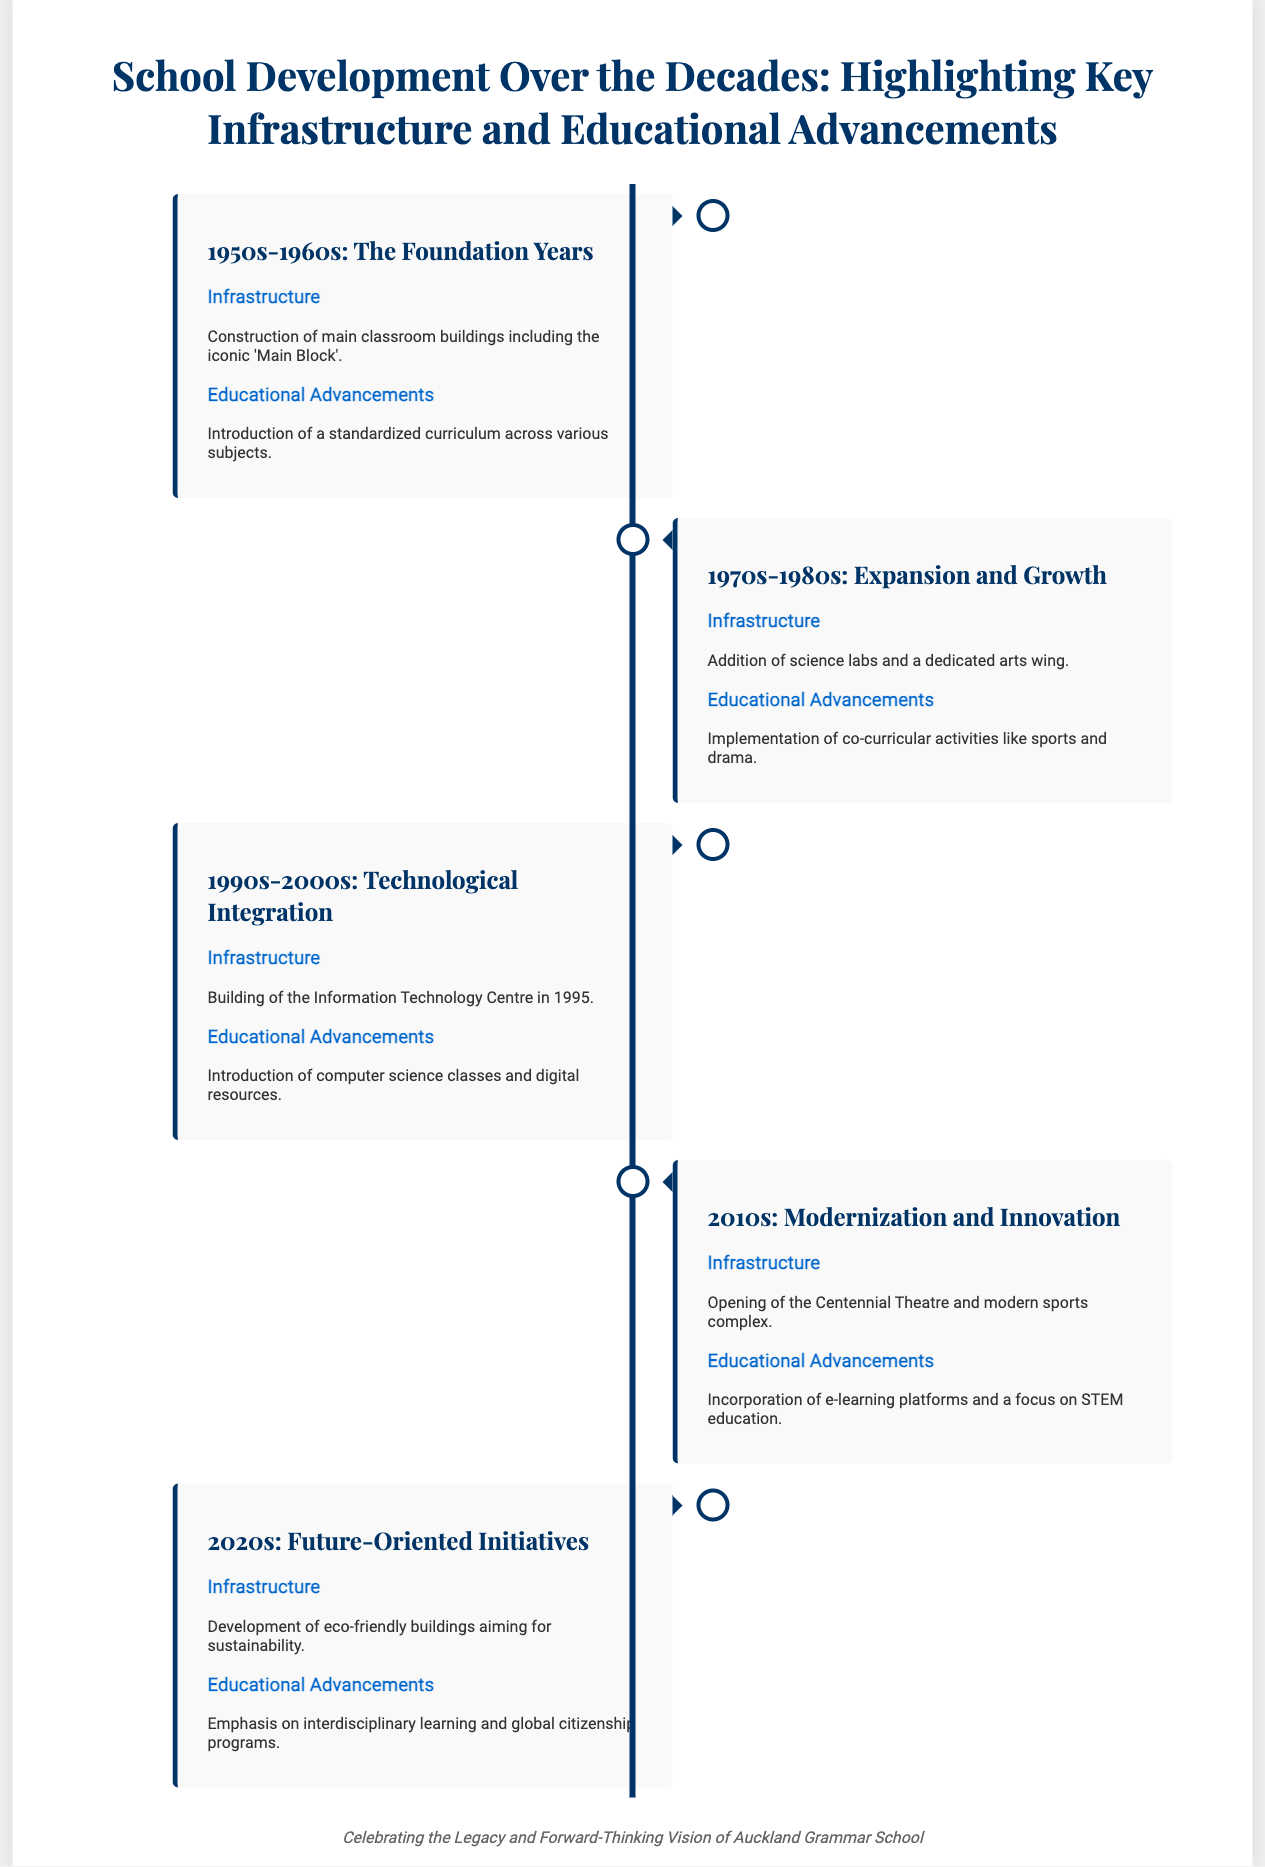What significant building was constructed in the 1950s-1960s? The document highlights the construction of the 'Main Block' as a significant building during the 1950s-1960s.
Answer: 'Main Block' What new facilities were added in the 1970s-1980s? The timeline states that science labs and a dedicated arts wing were added to the school during this period.
Answer: Science labs and arts wing Which year were computer science classes introduced? The introduction of computer science classes occurred in the 1990s-2000s as part of technological integration.
Answer: 1990s-2000s What is a key feature of the school's development in the 2010s? The document mentions the opening of the Centennial Theatre as a key infrastructure feature in the 2010s.
Answer: Centennial Theatre What initiative is emphasized in the 2020s? The emphasis on interdisciplinary learning and global citizenship programs is highlighted for the 2020s.
Answer: Interdisciplinary learning and global citizenship How does the document illustrate school development? The document uses a timeline format to illustrate the various phases of school development and advancements over the decades.
Answer: Timeline format What educational advancement was present in the 1970s-1980s? The implementation of co-curricular activities like sports and drama is noted as an educational advancement during this era.
Answer: Co-curricular activities Which decade saw the establishment of the Information Technology Centre? The document states that the Information Technology Centre was built in 1995, which falls under the 1990s-2000s timeframe.
Answer: 1990s-2000s What type of buildings is mentioned for the 2020s? The focus on developing eco-friendly buildings is mentioned as part of the school's initiative in the 2020s.
Answer: Eco-friendly buildings 